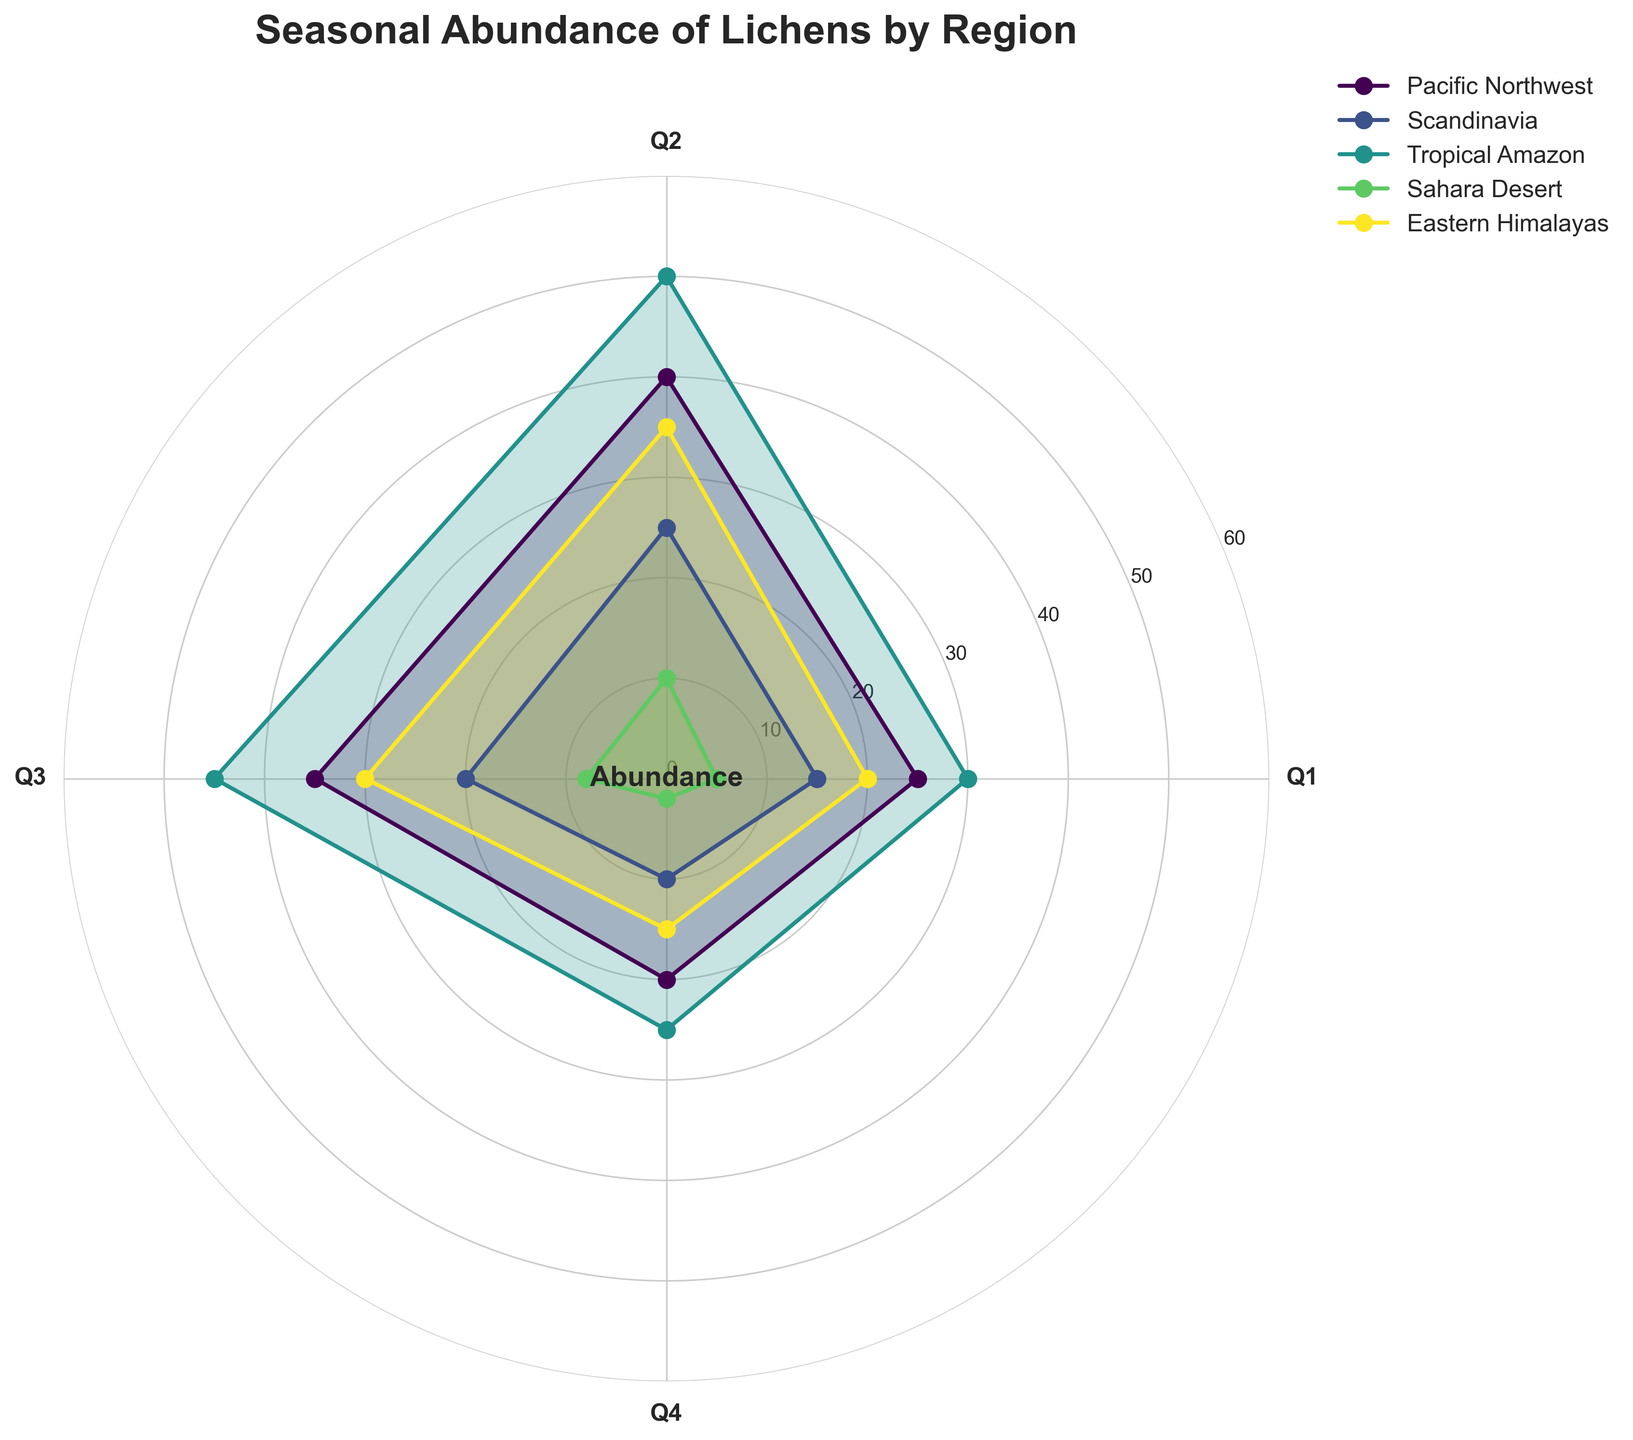What is the title of the chart? The title is typically found at the top of the chart and describes the data being visualized. In this case, the title clearly states the focus of the chart.
Answer: Seasonal Abundance of Lichens by Region How many regions are represented in the chart? By counting the number of unique lines represented in the legend, which usually correlates with the distinct regions, we can determine the number of regions.
Answer: 5 Which region has the highest abundance in Q2? The abundance values for Q2 can be compared across regions by looking at the data points' positions along the Q2 axis. The highest point corresponds to the Tropical Amazon.
Answer: Tropical Amazon What is the overall trend for the abundance of "Ramalina farinacea" in the Sahara Desert? By following the line representing the Sahara Desert across all quarters, we can observe how the abundance values change throughout the seasons. The values decrease from Q2 to Q4.
Answer: Decreasing Compare the abundance difference of "Leptogium cyanescens" between Q1 and Q3 in the Tropical Amazon. To find the difference, identify and subtract the abundance value of Q1 from Q3 for the Tropical Amazon. The values are 45 (Q3) and 30 (Q1), so the difference is 15.
Answer: 15 What region has the least seasonal variation in abundance for their respective lichen species? The region with the least variation will have the smallest difference between its highest and lowest abundance values. By comparing the range of values for each region, the Scandinavian region shows the smallest range (15).
Answer: Scandinavia Which season has the lowest abundance for "Peltigera rufescens" in the Eastern Himalayas? Inspecting the data points for "Peltigera rufescens" across all quarters revealed that Q4 has the lowest abundance, as the value is the smallest there.
Answer: Q4 What is the average abundance of "Cladonia rangiferina" across all seasons in the Pacific Northwest? Summing the abundance values for all four quarters and dividing by the number of quarters (4) gives the average abundance: (25 + 40 + 35 + 20) / 4 = 30.
Answer: 30 How does the abundance of "Evernia prunastri" in Q4 compare to that of "Ramalina farinacea" in Q1? To compare these two specific data points, locate them on the chart and contrast their values directly. "Evernia prunastri" in Q4 has an abundance of 10, while "Ramalina farinacea" in Q1 has an abundance of 5.
Answer: Greater 